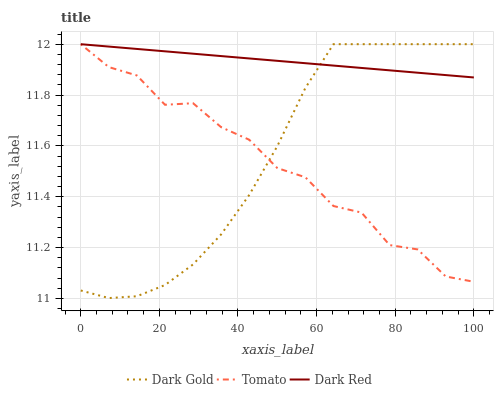Does Dark Gold have the minimum area under the curve?
Answer yes or no. No. Does Dark Gold have the maximum area under the curve?
Answer yes or no. No. Is Dark Gold the smoothest?
Answer yes or no. No. Is Dark Gold the roughest?
Answer yes or no. No. Does Dark Red have the lowest value?
Answer yes or no. No. 